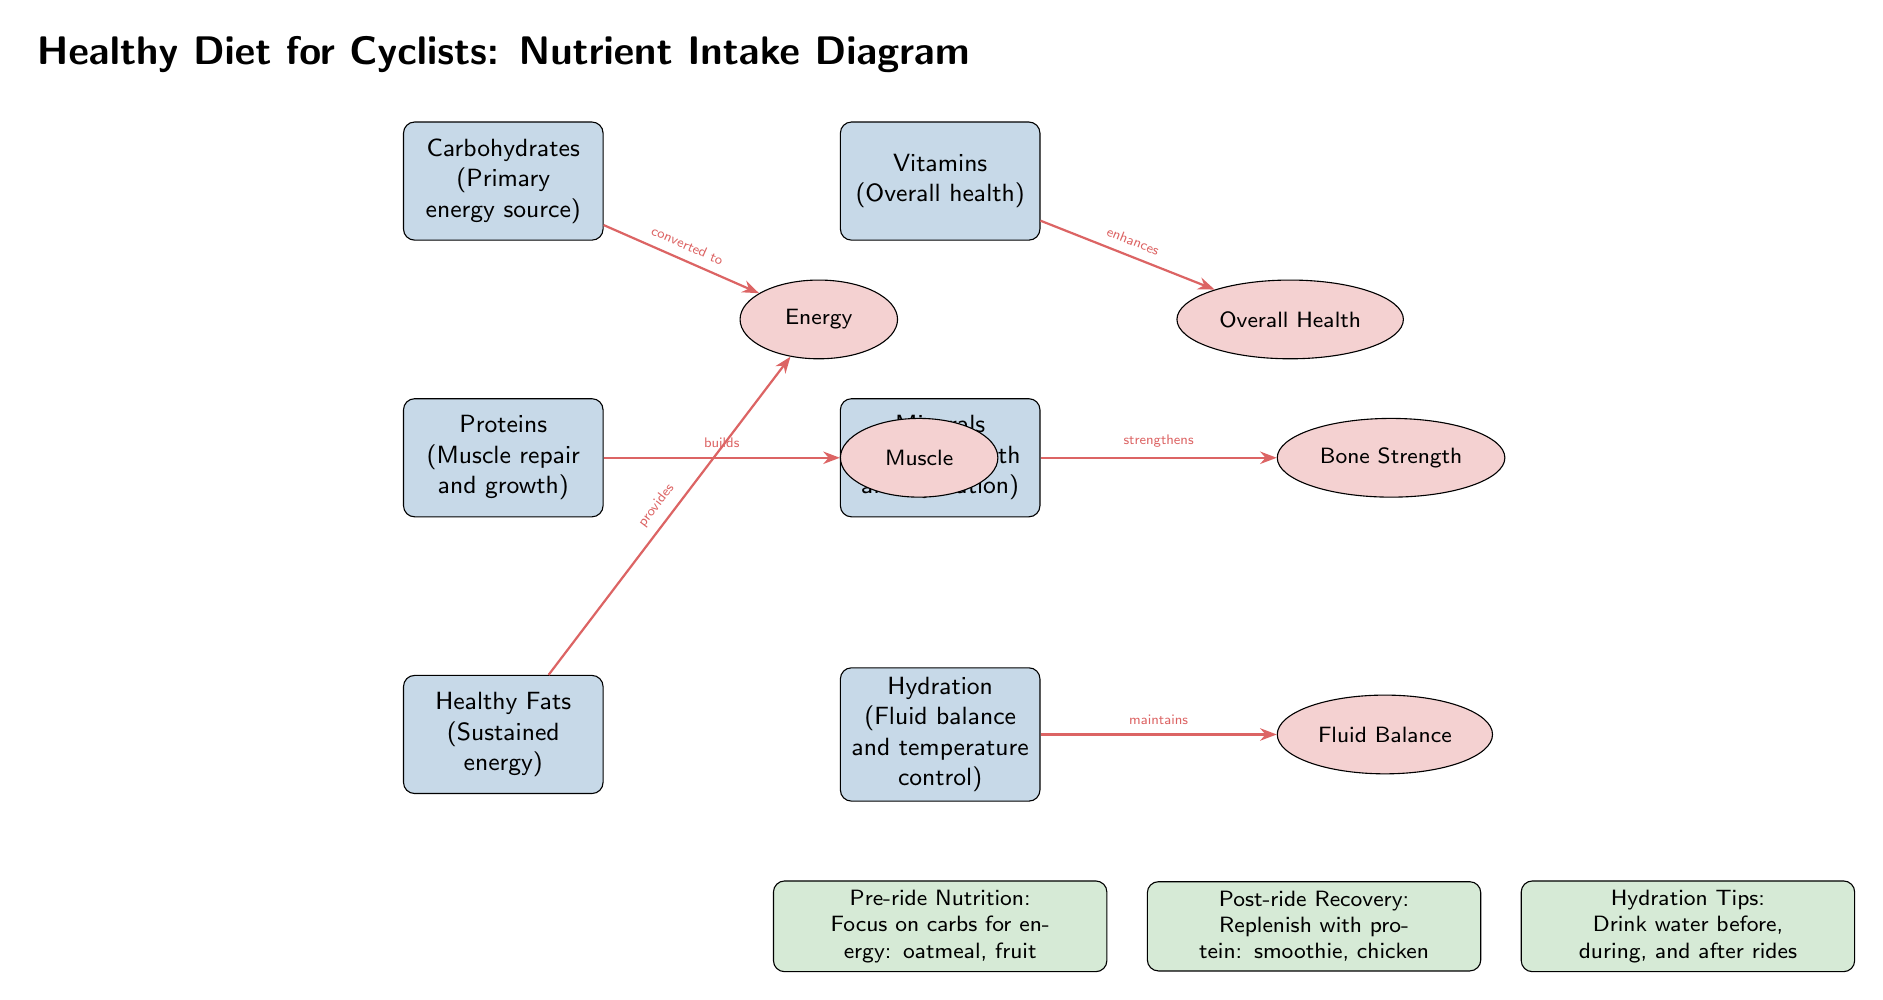What are the primary energy sources outlined in the diagram? The diagram lists carbohydrates as the primary energy source specifically stated in their description.
Answer: Carbohydrates How many nutrients are listed in the diagram? Counting the nodes labeled as nutrients, we have carbohydrates, proteins, healthy fats, vitamins, minerals, and hydration, totaling six nutrients.
Answer: 6 Which nutrient supports muscle repair and growth? The diagram directly attributes the function of muscle repair and growth to proteins as indicated in their description.
Answer: Proteins What relationship does hydration have with fluid balance? The diagram describes that hydration maintains fluid balance, showing a direct line (arrow) connecting hydration to fluid balance.
Answer: Maintains What foods are recommended for pre-ride nutrition according to the diagram? Under pre-ride nutrition in the diagram, the suggested foods are oatmeal and fruit, both aimed at providing energy through carbohydrates.
Answer: Oatmeal, fruit Which nutrient enhances overall health? The description next to vitamins explicitly states that vitamins enhance overall health, hence they are directly connected in that context.
Answer: Vitamins What type of fats are suggested for sustained energy? The diagram specifies healthy fats as the nutrients that provide sustained energy.
Answer: Healthy Fats How do proteins relate to muscle? The arrow drawn from proteins to the node labeled muscle indicates that proteins build muscle, as described in the diagram.
Answer: Builds What does the post-ride recovery emphasize in terms of nutrient intake? According to the diagram, post-ride recovery emphasizes replenishing with protein, specifically mentioning foods like smoothie and chicken.
Answer: Protein: smoothie, chicken 